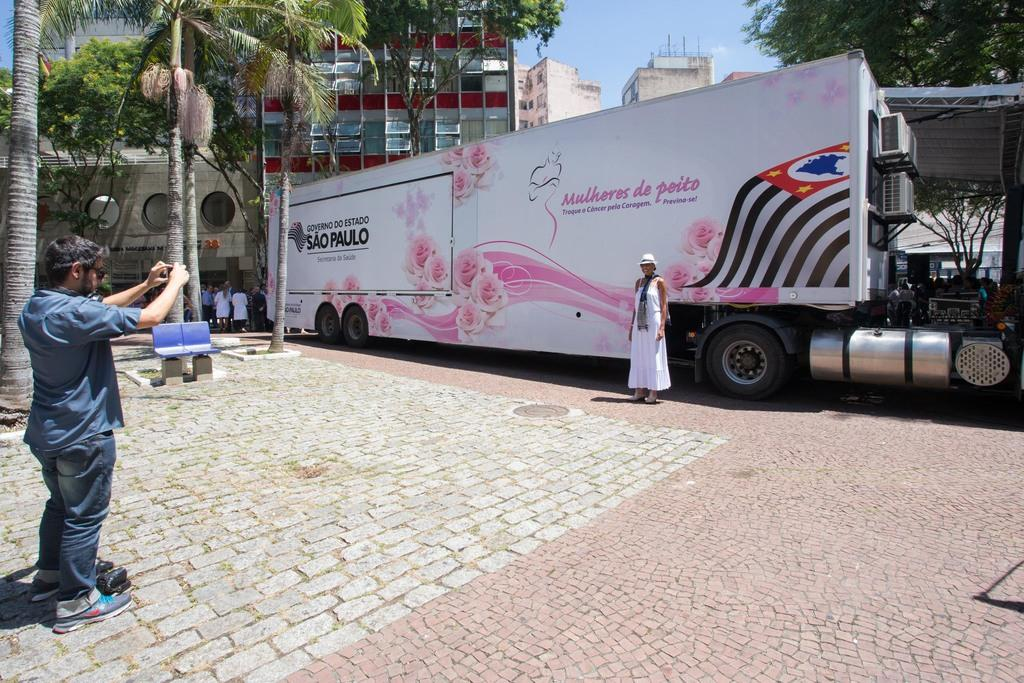How many people are in the image? There are people in the image, but the exact number is not specified. What is the surface beneath the people? There is a floor in the image. What type of furniture is present in the image? There are chairs in the image. What type of natural element is visible in the image? There are trees in the image. What type of transportation is in the image? There is a vehicle in the image. What type of structure is present in the image? There is a shed in the image. What type of man-made structures are visible in the image? There are buildings in the image. What is visible in the background of the image? The sky is visible in the background of the image. Can you tell me how many mountains are visible in the image? There are no mountains visible in the image. What type of nut is being discovered by the people in the image? There is no mention of a nut or any discovery in the image. 